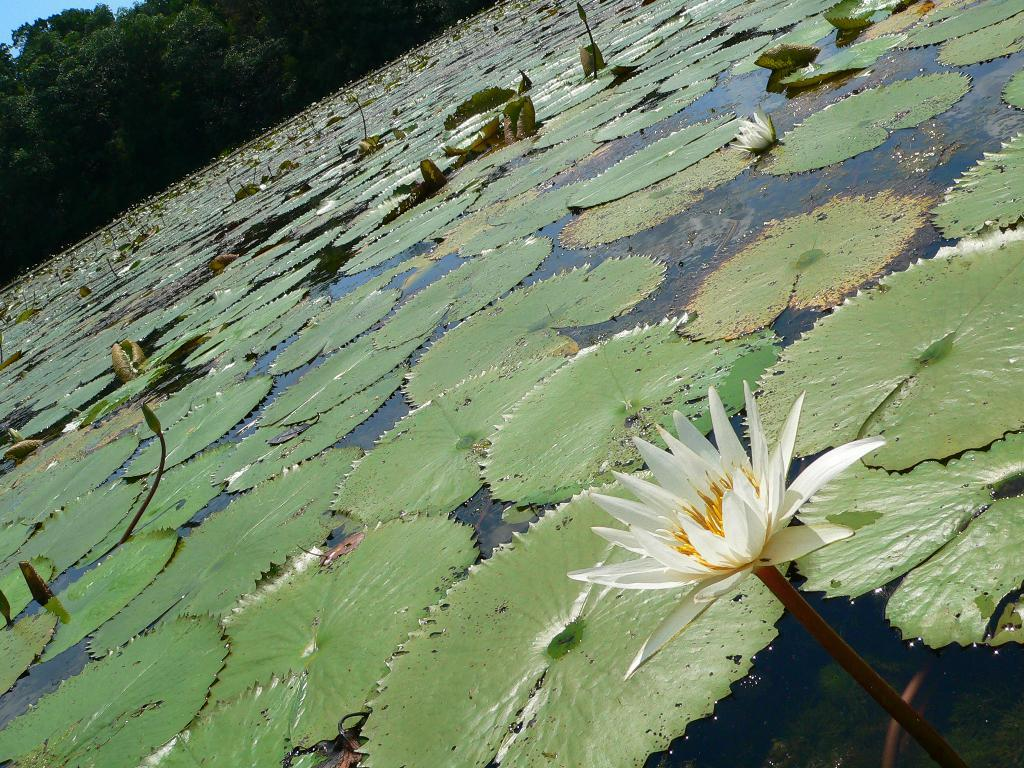What is floating on the water in the image? There are leaves floating on water in the image. What can be seen in the front of the image? There is a flower in the front of the image. What type of vegetation is visible in the background of the image? There are trees in the background of the image. What is the level of anger displayed by the toad in the image? There is no toad present in the image, so it is not possible to determine the level of anger displayed. 